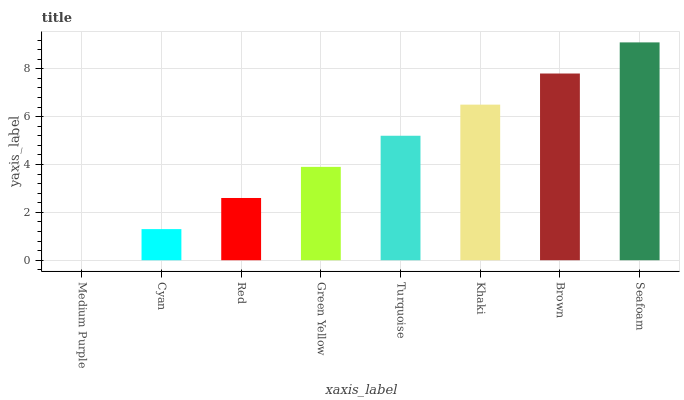Is Medium Purple the minimum?
Answer yes or no. Yes. Is Seafoam the maximum?
Answer yes or no. Yes. Is Cyan the minimum?
Answer yes or no. No. Is Cyan the maximum?
Answer yes or no. No. Is Cyan greater than Medium Purple?
Answer yes or no. Yes. Is Medium Purple less than Cyan?
Answer yes or no. Yes. Is Medium Purple greater than Cyan?
Answer yes or no. No. Is Cyan less than Medium Purple?
Answer yes or no. No. Is Turquoise the high median?
Answer yes or no. Yes. Is Green Yellow the low median?
Answer yes or no. Yes. Is Seafoam the high median?
Answer yes or no. No. Is Medium Purple the low median?
Answer yes or no. No. 